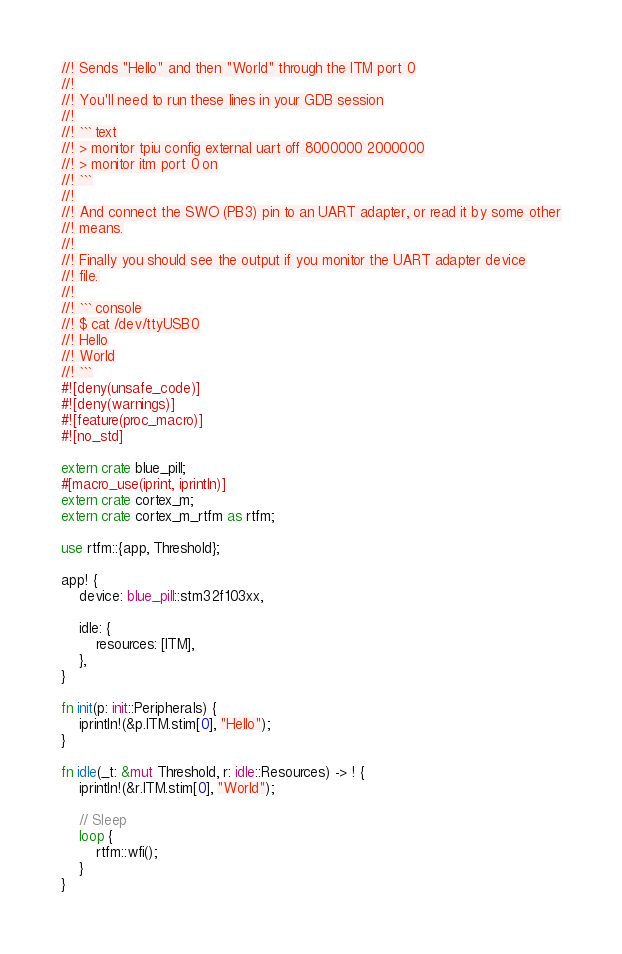<code> <loc_0><loc_0><loc_500><loc_500><_Rust_>//! Sends "Hello" and then "World" through the ITM port 0
//!
//! You'll need to run these lines in your GDB session
//!
//! ``` text
//! > monitor tpiu config external uart off 8000000 2000000
//! > monitor itm port 0 on
//! ```
//!
//! And connect the SWO (PB3) pin to an UART adapter, or read it by some other
//! means.
//!
//! Finally you should see the output if you monitor the UART adapter device
//! file.
//!
//! ``` console
//! $ cat /dev/ttyUSB0
//! Hello
//! World
//! ```
#![deny(unsafe_code)]
#![deny(warnings)]
#![feature(proc_macro)]
#![no_std]

extern crate blue_pill;
#[macro_use(iprint, iprintln)]
extern crate cortex_m;
extern crate cortex_m_rtfm as rtfm;

use rtfm::{app, Threshold};

app! {
    device: blue_pill::stm32f103xx,

    idle: {
        resources: [ITM],
    },
}

fn init(p: init::Peripherals) {
    iprintln!(&p.ITM.stim[0], "Hello");
}

fn idle(_t: &mut Threshold, r: idle::Resources) -> ! {
    iprintln!(&r.ITM.stim[0], "World");

    // Sleep
    loop {
        rtfm::wfi();
    }
}
</code> 